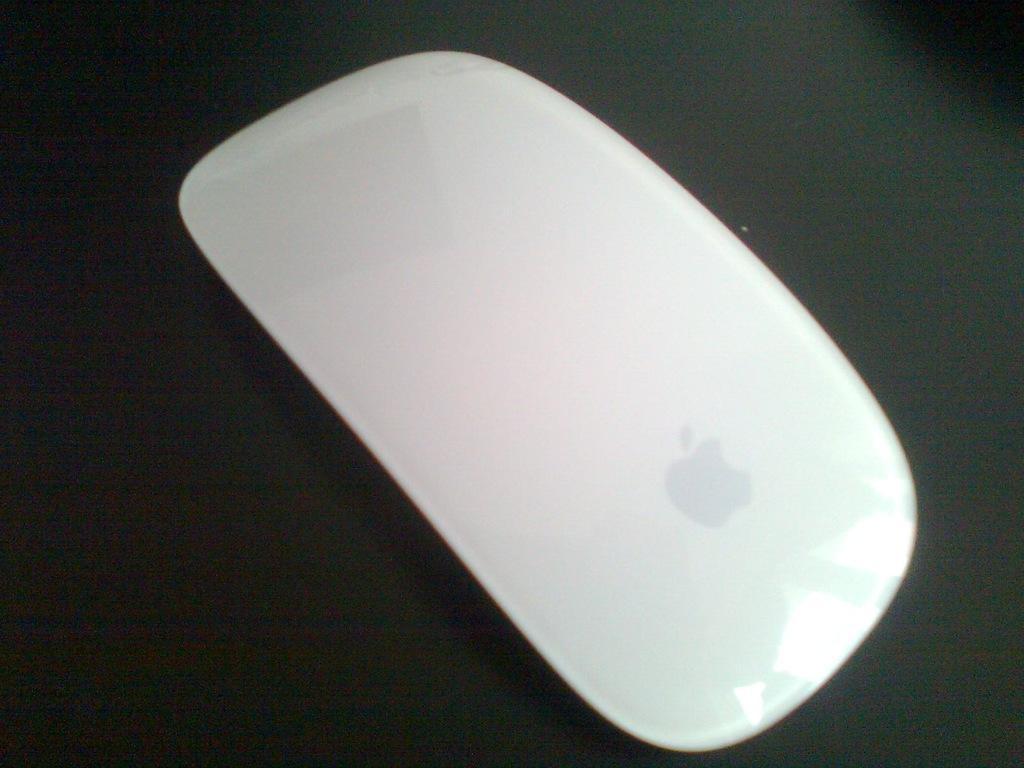Can you describe this image briefly? In this image there is a mouse on the black color surface. 